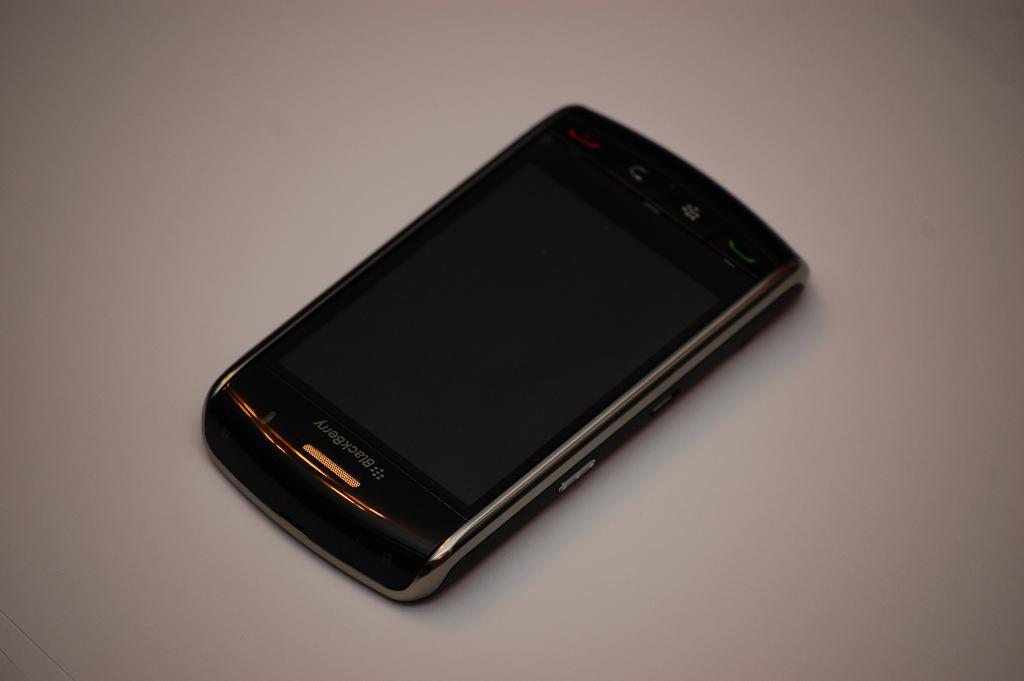Provide a one-sentence caption for the provided image. A black blackberry cell phone laying on the display. 